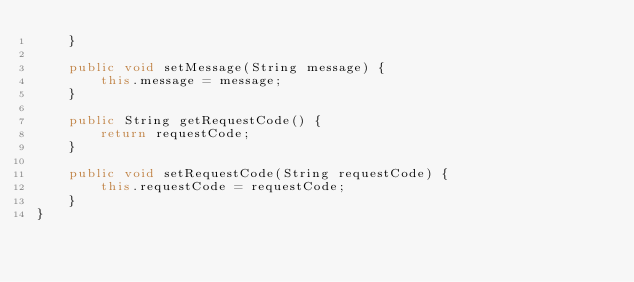<code> <loc_0><loc_0><loc_500><loc_500><_Java_>    }

    public void setMessage(String message) {
        this.message = message;
    }

    public String getRequestCode() {
        return requestCode;
    }

    public void setRequestCode(String requestCode) {
        this.requestCode = requestCode;
    }
}
</code> 